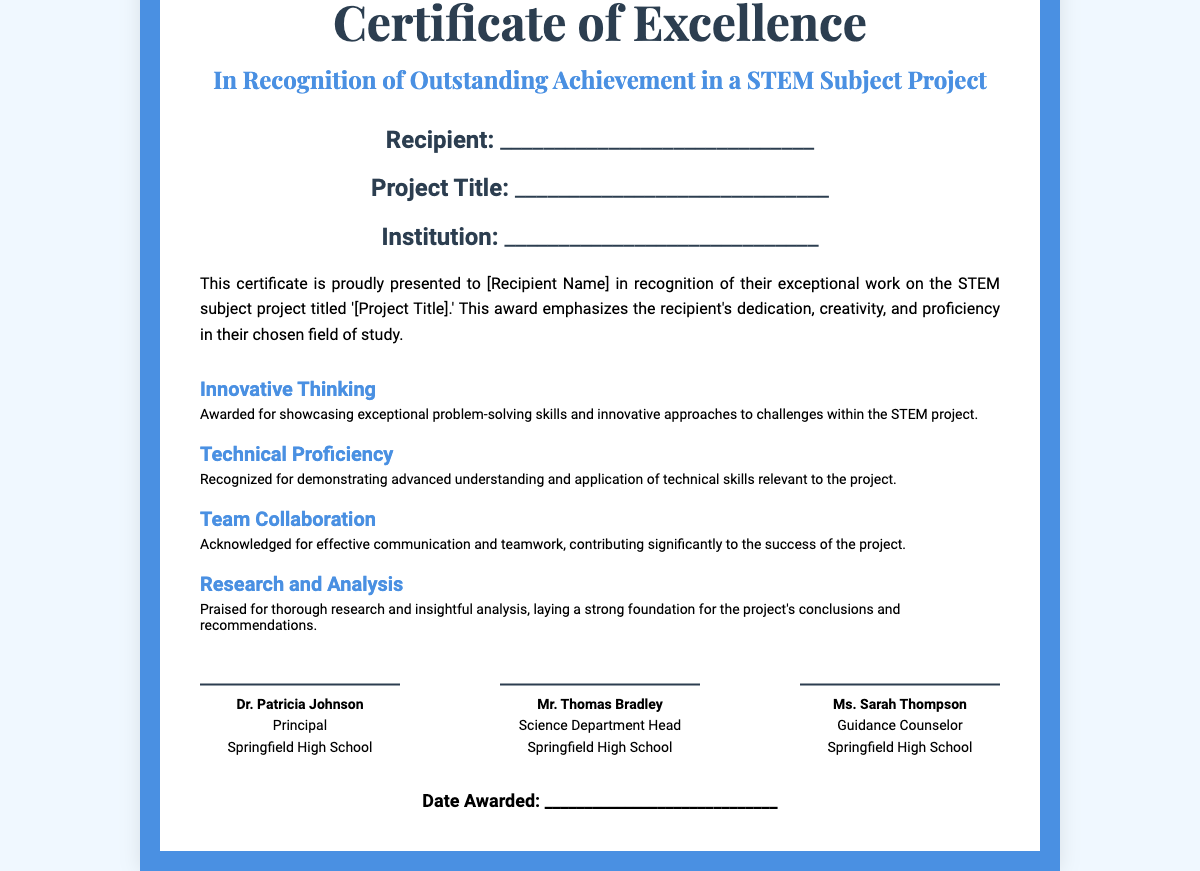What is the title of the certificate? The title of the certificate is found at the top of the document.
Answer: Certificate of Excellence Who is the recipient of the certificate? The recipient's name is a blank space designated for filling in.
Answer: _____________________________ What is the project title? The project title is a blank space listed below the recipient's information.
Answer: _____________________________ What does the description emphasize about the recipient? The description highlights the attributes recognized in the recipient's work on the project.
Answer: Dedication, creativity, and proficiency Which skill is associated with "Innovative Thinking"? This section details the skills recognized for the recipient of the certificate.
Answer: Exceptional problem-solving skills How many criteria are listed in the certificate? Counting the headers in the criteria section provides the total number of recognized abilities.
Answer: 4 Who is the principal signing the certificate? The document provides the name and position of the person signing it.
Answer: Dr. Patricia Johnson What is the date awarded? This information is a blank space for filling in the date of issuance.
Answer: _____________________________ What institution is mentioned on the certificate? The institution is indicated in a designated area on the document.
Answer: _____________________________ 